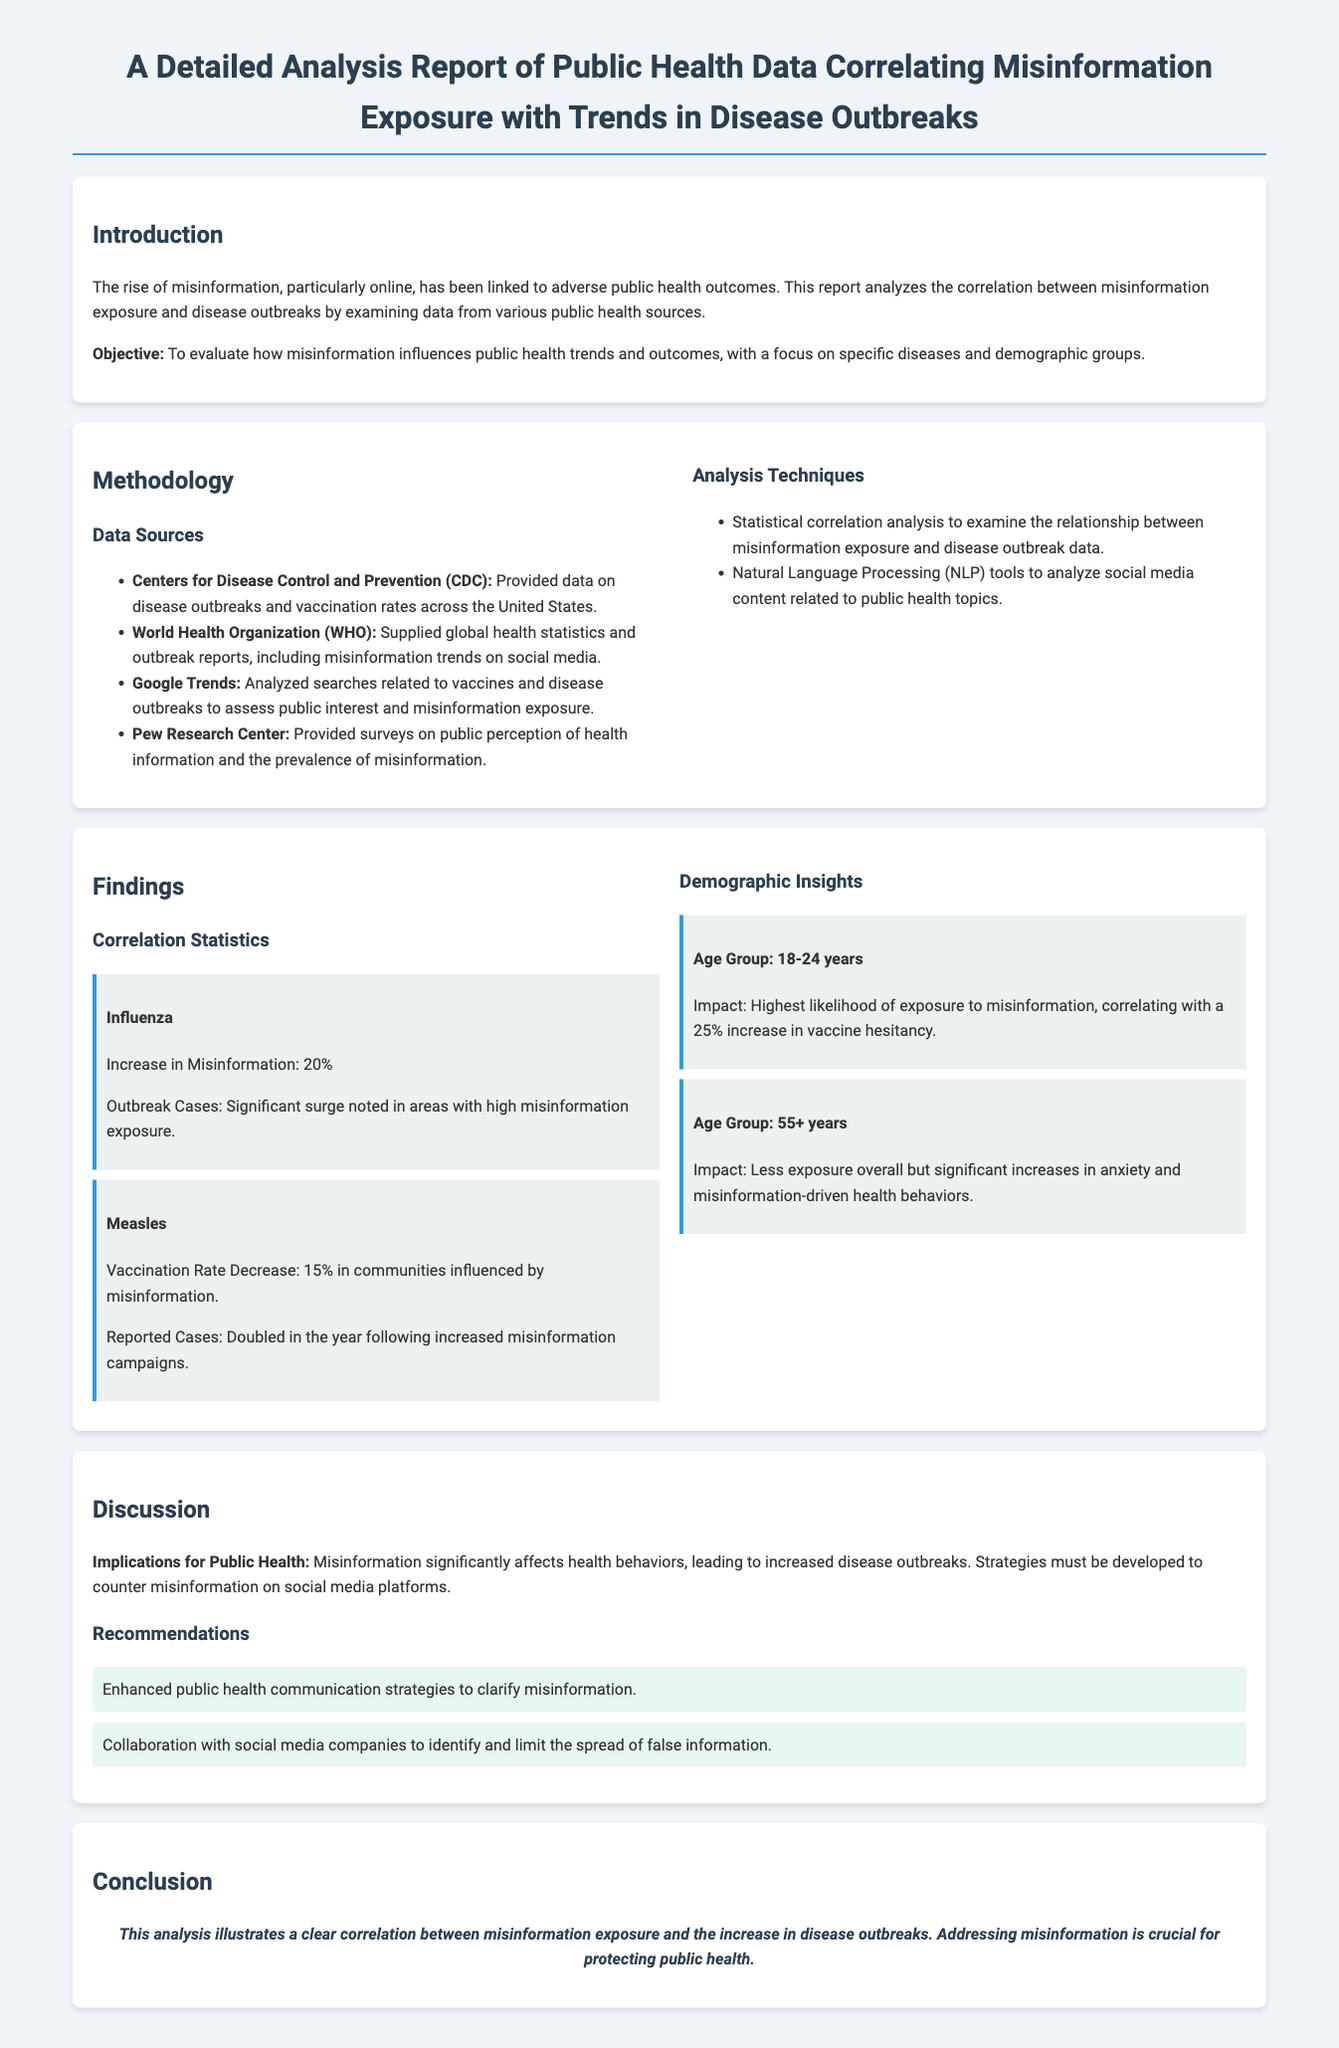What is the objective of the report? The objective is to evaluate how misinformation influences public health trends and outcomes.
Answer: To evaluate how misinformation influences public health trends and outcomes What percentage increase in misinformation was noted for influenza? The document states that there was a 20% increase in misinformation for influenza.
Answer: 20% Which age group shows the highest likelihood of exposure to misinformation? The report identifies the age group 18-24 years as having the highest likelihood of exposure to misinformation.
Answer: 18-24 years What was the vaccination rate decrease for measles in communities influenced by misinformation? The vaccination rate decrease for measles was reported to be 15%.
Answer: 15% How many recommendations are provided in the report? The report provides two recommendations in the recommendations section.
Answer: Two What key implication does the report emphasize regarding misinformation? The report emphasizes that misinformation significantly affects health behaviors, leading to increased disease outbreaks.
Answer: Increased disease outbreaks What analytic tools were used to analyze social media content? Natural Language Processing tools were used to analyze social media content.
Answer: Natural Language Processing tools What overall conclusion is drawn in the report? The conclusion states that there is a clear correlation between misinformation exposure and the increase in disease outbreaks.
Answer: Correlation between misinformation exposure and increase in disease outbreaks 